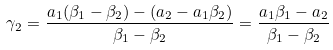Convert formula to latex. <formula><loc_0><loc_0><loc_500><loc_500>\gamma _ { 2 } = \frac { a _ { 1 } ( \beta _ { 1 } - \beta _ { 2 } ) - ( a _ { 2 } - a _ { 1 } \beta _ { 2 } ) } { \beta _ { 1 } - \beta _ { 2 } } = \frac { a _ { 1 } \beta _ { 1 } - a _ { 2 } } { \beta _ { 1 } - \beta _ { 2 } }</formula> 